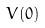<formula> <loc_0><loc_0><loc_500><loc_500>V ( 0 )</formula> 